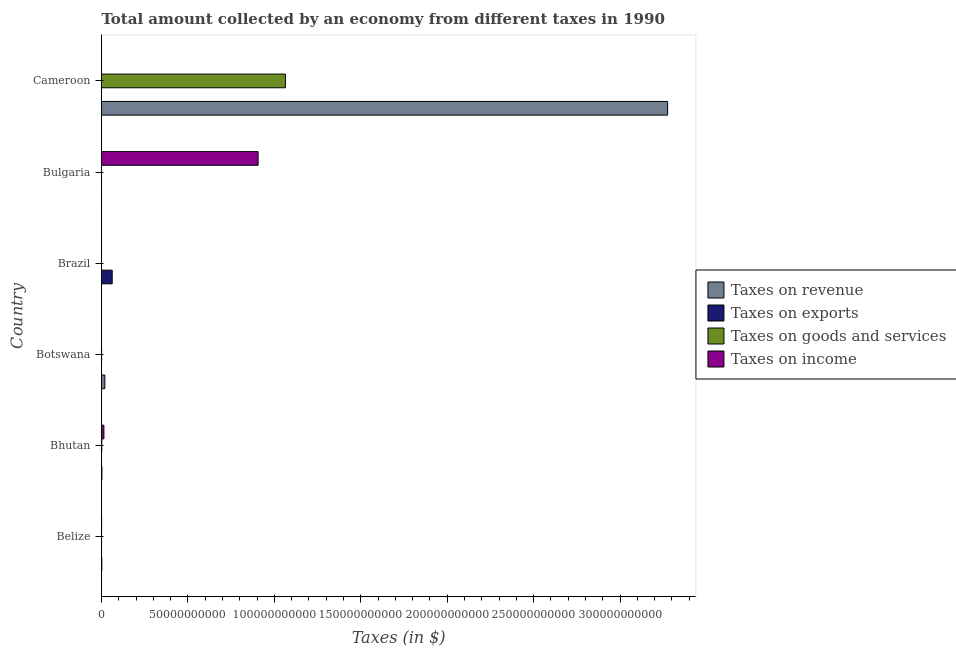How many different coloured bars are there?
Your answer should be compact. 4. How many groups of bars are there?
Your answer should be compact. 6. Are the number of bars on each tick of the Y-axis equal?
Your response must be concise. Yes. How many bars are there on the 2nd tick from the top?
Ensure brevity in your answer.  4. How many bars are there on the 6th tick from the bottom?
Provide a short and direct response. 4. What is the label of the 5th group of bars from the top?
Offer a very short reply. Bhutan. In how many cases, is the number of bars for a given country not equal to the number of legend labels?
Offer a terse response. 0. What is the amount collected as tax on goods in Cameroon?
Your answer should be very brief. 1.06e+11. Across all countries, what is the maximum amount collected as tax on income?
Provide a succinct answer. 9.06e+1. Across all countries, what is the minimum amount collected as tax on income?
Provide a succinct answer. 0.6. In which country was the amount collected as tax on revenue maximum?
Offer a very short reply. Cameroon. In which country was the amount collected as tax on exports minimum?
Your response must be concise. Bulgaria. What is the total amount collected as tax on revenue in the graph?
Offer a terse response. 3.30e+11. What is the difference between the amount collected as tax on revenue in Bhutan and that in Bulgaria?
Provide a short and direct response. 2.21e+08. What is the difference between the amount collected as tax on goods in Botswana and the amount collected as tax on revenue in Bhutan?
Keep it short and to the point. -1.64e+08. What is the average amount collected as tax on goods per country?
Ensure brevity in your answer.  1.78e+1. What is the difference between the amount collected as tax on revenue and amount collected as tax on income in Cameroon?
Give a very brief answer. 3.27e+11. In how many countries, is the amount collected as tax on income greater than 10000000000 $?
Make the answer very short. 1. Is the amount collected as tax on goods in Bulgaria less than that in Cameroon?
Ensure brevity in your answer.  Yes. Is the difference between the amount collected as tax on goods in Brazil and Cameroon greater than the difference between the amount collected as tax on revenue in Brazil and Cameroon?
Make the answer very short. Yes. What is the difference between the highest and the second highest amount collected as tax on income?
Your answer should be very brief. 8.92e+1. What is the difference between the highest and the lowest amount collected as tax on exports?
Give a very brief answer. 6.18e+09. What does the 1st bar from the top in Bulgaria represents?
Your response must be concise. Taxes on income. What does the 1st bar from the bottom in Cameroon represents?
Keep it short and to the point. Taxes on revenue. Is it the case that in every country, the sum of the amount collected as tax on revenue and amount collected as tax on exports is greater than the amount collected as tax on goods?
Ensure brevity in your answer.  Yes. What is the difference between two consecutive major ticks on the X-axis?
Offer a terse response. 5.00e+1. Are the values on the major ticks of X-axis written in scientific E-notation?
Keep it short and to the point. No. Does the graph contain any zero values?
Keep it short and to the point. No. Where does the legend appear in the graph?
Give a very brief answer. Center right. How many legend labels are there?
Give a very brief answer. 4. What is the title of the graph?
Your answer should be compact. Total amount collected by an economy from different taxes in 1990. What is the label or title of the X-axis?
Provide a succinct answer. Taxes (in $). What is the Taxes (in $) in Taxes on revenue in Belize?
Your answer should be very brief. 1.77e+08. What is the Taxes (in $) in Taxes on exports in Belize?
Your response must be concise. 2.60e+06. What is the Taxes (in $) of Taxes on goods and services in Belize?
Make the answer very short. 2.05e+07. What is the Taxes (in $) of Taxes on income in Belize?
Provide a succinct answer. 7.12e+07. What is the Taxes (in $) in Taxes on revenue in Bhutan?
Your answer should be very brief. 2.32e+08. What is the Taxes (in $) in Taxes on exports in Bhutan?
Keep it short and to the point. 4.40e+05. What is the Taxes (in $) in Taxes on goods and services in Bhutan?
Offer a terse response. 1.52e+08. What is the Taxes (in $) in Taxes on income in Bhutan?
Offer a terse response. 1.39e+09. What is the Taxes (in $) of Taxes on revenue in Botswana?
Your response must be concise. 1.94e+09. What is the Taxes (in $) in Taxes on exports in Botswana?
Make the answer very short. 1018.18. What is the Taxes (in $) of Taxes on goods and services in Botswana?
Give a very brief answer. 6.75e+07. What is the Taxes (in $) in Taxes on income in Botswana?
Your answer should be compact. 5.39e+05. What is the Taxes (in $) in Taxes on revenue in Brazil?
Give a very brief answer. 1.39e+06. What is the Taxes (in $) of Taxes on exports in Brazil?
Provide a succinct answer. 6.18e+09. What is the Taxes (in $) of Taxes on goods and services in Brazil?
Make the answer very short. 6.37e+05. What is the Taxes (in $) in Taxes on income in Brazil?
Provide a succinct answer. 6.35e+06. What is the Taxes (in $) of Taxes on revenue in Bulgaria?
Your answer should be compact. 1.08e+07. What is the Taxes (in $) in Taxes on exports in Bulgaria?
Give a very brief answer. 0.09. What is the Taxes (in $) in Taxes on goods and services in Bulgaria?
Offer a very short reply. 3.88e+06. What is the Taxes (in $) of Taxes on income in Bulgaria?
Provide a succinct answer. 9.06e+1. What is the Taxes (in $) of Taxes on revenue in Cameroon?
Keep it short and to the point. 3.27e+11. What is the Taxes (in $) in Taxes on exports in Cameroon?
Provide a succinct answer. 5.00e+06. What is the Taxes (in $) in Taxes on goods and services in Cameroon?
Ensure brevity in your answer.  1.06e+11. What is the Taxes (in $) of Taxes on income in Cameroon?
Your answer should be compact. 0.6. Across all countries, what is the maximum Taxes (in $) in Taxes on revenue?
Provide a short and direct response. 3.27e+11. Across all countries, what is the maximum Taxes (in $) of Taxes on exports?
Offer a very short reply. 6.18e+09. Across all countries, what is the maximum Taxes (in $) of Taxes on goods and services?
Offer a terse response. 1.06e+11. Across all countries, what is the maximum Taxes (in $) in Taxes on income?
Offer a terse response. 9.06e+1. Across all countries, what is the minimum Taxes (in $) in Taxes on revenue?
Provide a short and direct response. 1.39e+06. Across all countries, what is the minimum Taxes (in $) of Taxes on exports?
Your response must be concise. 0.09. Across all countries, what is the minimum Taxes (in $) of Taxes on goods and services?
Keep it short and to the point. 6.37e+05. Across all countries, what is the minimum Taxes (in $) in Taxes on income?
Make the answer very short. 0.6. What is the total Taxes (in $) of Taxes on revenue in the graph?
Keep it short and to the point. 3.30e+11. What is the total Taxes (in $) of Taxes on exports in the graph?
Your answer should be compact. 6.19e+09. What is the total Taxes (in $) of Taxes on goods and services in the graph?
Keep it short and to the point. 1.07e+11. What is the total Taxes (in $) of Taxes on income in the graph?
Keep it short and to the point. 9.21e+1. What is the difference between the Taxes (in $) in Taxes on revenue in Belize and that in Bhutan?
Your answer should be compact. -5.49e+07. What is the difference between the Taxes (in $) in Taxes on exports in Belize and that in Bhutan?
Offer a very short reply. 2.16e+06. What is the difference between the Taxes (in $) of Taxes on goods and services in Belize and that in Bhutan?
Your response must be concise. -1.32e+08. What is the difference between the Taxes (in $) of Taxes on income in Belize and that in Bhutan?
Provide a succinct answer. -1.32e+09. What is the difference between the Taxes (in $) of Taxes on revenue in Belize and that in Botswana?
Your answer should be very brief. -1.76e+09. What is the difference between the Taxes (in $) of Taxes on exports in Belize and that in Botswana?
Your response must be concise. 2.60e+06. What is the difference between the Taxes (in $) of Taxes on goods and services in Belize and that in Botswana?
Ensure brevity in your answer.  -4.70e+07. What is the difference between the Taxes (in $) of Taxes on income in Belize and that in Botswana?
Provide a short and direct response. 7.07e+07. What is the difference between the Taxes (in $) of Taxes on revenue in Belize and that in Brazil?
Offer a terse response. 1.75e+08. What is the difference between the Taxes (in $) of Taxes on exports in Belize and that in Brazil?
Ensure brevity in your answer.  -6.18e+09. What is the difference between the Taxes (in $) of Taxes on goods and services in Belize and that in Brazil?
Your answer should be compact. 1.98e+07. What is the difference between the Taxes (in $) in Taxes on income in Belize and that in Brazil?
Keep it short and to the point. 6.48e+07. What is the difference between the Taxes (in $) of Taxes on revenue in Belize and that in Bulgaria?
Your answer should be compact. 1.66e+08. What is the difference between the Taxes (in $) in Taxes on exports in Belize and that in Bulgaria?
Provide a succinct answer. 2.60e+06. What is the difference between the Taxes (in $) in Taxes on goods and services in Belize and that in Bulgaria?
Offer a terse response. 1.66e+07. What is the difference between the Taxes (in $) in Taxes on income in Belize and that in Bulgaria?
Provide a succinct answer. -9.05e+1. What is the difference between the Taxes (in $) in Taxes on revenue in Belize and that in Cameroon?
Offer a very short reply. -3.27e+11. What is the difference between the Taxes (in $) in Taxes on exports in Belize and that in Cameroon?
Ensure brevity in your answer.  -2.40e+06. What is the difference between the Taxes (in $) of Taxes on goods and services in Belize and that in Cameroon?
Provide a succinct answer. -1.06e+11. What is the difference between the Taxes (in $) of Taxes on income in Belize and that in Cameroon?
Provide a short and direct response. 7.12e+07. What is the difference between the Taxes (in $) of Taxes on revenue in Bhutan and that in Botswana?
Provide a short and direct response. -1.71e+09. What is the difference between the Taxes (in $) in Taxes on exports in Bhutan and that in Botswana?
Your answer should be very brief. 4.39e+05. What is the difference between the Taxes (in $) of Taxes on goods and services in Bhutan and that in Botswana?
Offer a very short reply. 8.46e+07. What is the difference between the Taxes (in $) of Taxes on income in Bhutan and that in Botswana?
Make the answer very short. 1.39e+09. What is the difference between the Taxes (in $) of Taxes on revenue in Bhutan and that in Brazil?
Give a very brief answer. 2.30e+08. What is the difference between the Taxes (in $) of Taxes on exports in Bhutan and that in Brazil?
Provide a succinct answer. -6.18e+09. What is the difference between the Taxes (in $) in Taxes on goods and services in Bhutan and that in Brazil?
Keep it short and to the point. 1.51e+08. What is the difference between the Taxes (in $) of Taxes on income in Bhutan and that in Brazil?
Your answer should be compact. 1.38e+09. What is the difference between the Taxes (in $) in Taxes on revenue in Bhutan and that in Bulgaria?
Provide a short and direct response. 2.21e+08. What is the difference between the Taxes (in $) in Taxes on exports in Bhutan and that in Bulgaria?
Provide a short and direct response. 4.40e+05. What is the difference between the Taxes (in $) in Taxes on goods and services in Bhutan and that in Bulgaria?
Provide a short and direct response. 1.48e+08. What is the difference between the Taxes (in $) in Taxes on income in Bhutan and that in Bulgaria?
Give a very brief answer. -8.92e+1. What is the difference between the Taxes (in $) of Taxes on revenue in Bhutan and that in Cameroon?
Offer a very short reply. -3.27e+11. What is the difference between the Taxes (in $) of Taxes on exports in Bhutan and that in Cameroon?
Your answer should be compact. -4.56e+06. What is the difference between the Taxes (in $) of Taxes on goods and services in Bhutan and that in Cameroon?
Your answer should be very brief. -1.06e+11. What is the difference between the Taxes (in $) in Taxes on income in Bhutan and that in Cameroon?
Make the answer very short. 1.39e+09. What is the difference between the Taxes (in $) in Taxes on revenue in Botswana and that in Brazil?
Provide a succinct answer. 1.94e+09. What is the difference between the Taxes (in $) in Taxes on exports in Botswana and that in Brazil?
Your answer should be very brief. -6.18e+09. What is the difference between the Taxes (in $) in Taxes on goods and services in Botswana and that in Brazil?
Keep it short and to the point. 6.69e+07. What is the difference between the Taxes (in $) of Taxes on income in Botswana and that in Brazil?
Provide a succinct answer. -5.81e+06. What is the difference between the Taxes (in $) in Taxes on revenue in Botswana and that in Bulgaria?
Offer a terse response. 1.93e+09. What is the difference between the Taxes (in $) of Taxes on exports in Botswana and that in Bulgaria?
Offer a very short reply. 1018.1. What is the difference between the Taxes (in $) in Taxes on goods and services in Botswana and that in Bulgaria?
Keep it short and to the point. 6.36e+07. What is the difference between the Taxes (in $) of Taxes on income in Botswana and that in Bulgaria?
Offer a very short reply. -9.06e+1. What is the difference between the Taxes (in $) in Taxes on revenue in Botswana and that in Cameroon?
Ensure brevity in your answer.  -3.26e+11. What is the difference between the Taxes (in $) of Taxes on exports in Botswana and that in Cameroon?
Offer a very short reply. -5.00e+06. What is the difference between the Taxes (in $) of Taxes on goods and services in Botswana and that in Cameroon?
Make the answer very short. -1.06e+11. What is the difference between the Taxes (in $) in Taxes on income in Botswana and that in Cameroon?
Provide a short and direct response. 5.39e+05. What is the difference between the Taxes (in $) in Taxes on revenue in Brazil and that in Bulgaria?
Offer a terse response. -9.43e+06. What is the difference between the Taxes (in $) of Taxes on exports in Brazil and that in Bulgaria?
Offer a very short reply. 6.18e+09. What is the difference between the Taxes (in $) in Taxes on goods and services in Brazil and that in Bulgaria?
Provide a short and direct response. -3.24e+06. What is the difference between the Taxes (in $) in Taxes on income in Brazil and that in Bulgaria?
Make the answer very short. -9.06e+1. What is the difference between the Taxes (in $) of Taxes on revenue in Brazil and that in Cameroon?
Your answer should be compact. -3.27e+11. What is the difference between the Taxes (in $) in Taxes on exports in Brazil and that in Cameroon?
Give a very brief answer. 6.18e+09. What is the difference between the Taxes (in $) in Taxes on goods and services in Brazil and that in Cameroon?
Provide a short and direct response. -1.06e+11. What is the difference between the Taxes (in $) in Taxes on income in Brazil and that in Cameroon?
Your response must be concise. 6.35e+06. What is the difference between the Taxes (in $) of Taxes on revenue in Bulgaria and that in Cameroon?
Offer a very short reply. -3.27e+11. What is the difference between the Taxes (in $) in Taxes on exports in Bulgaria and that in Cameroon?
Provide a succinct answer. -5.00e+06. What is the difference between the Taxes (in $) in Taxes on goods and services in Bulgaria and that in Cameroon?
Your response must be concise. -1.06e+11. What is the difference between the Taxes (in $) of Taxes on income in Bulgaria and that in Cameroon?
Keep it short and to the point. 9.06e+1. What is the difference between the Taxes (in $) in Taxes on revenue in Belize and the Taxes (in $) in Taxes on exports in Bhutan?
Your answer should be very brief. 1.76e+08. What is the difference between the Taxes (in $) of Taxes on revenue in Belize and the Taxes (in $) of Taxes on goods and services in Bhutan?
Give a very brief answer. 2.47e+07. What is the difference between the Taxes (in $) in Taxes on revenue in Belize and the Taxes (in $) in Taxes on income in Bhutan?
Offer a very short reply. -1.21e+09. What is the difference between the Taxes (in $) of Taxes on exports in Belize and the Taxes (in $) of Taxes on goods and services in Bhutan?
Keep it short and to the point. -1.49e+08. What is the difference between the Taxes (in $) of Taxes on exports in Belize and the Taxes (in $) of Taxes on income in Bhutan?
Provide a short and direct response. -1.39e+09. What is the difference between the Taxes (in $) in Taxes on goods and services in Belize and the Taxes (in $) in Taxes on income in Bhutan?
Offer a very short reply. -1.37e+09. What is the difference between the Taxes (in $) of Taxes on revenue in Belize and the Taxes (in $) of Taxes on exports in Botswana?
Your answer should be compact. 1.77e+08. What is the difference between the Taxes (in $) of Taxes on revenue in Belize and the Taxes (in $) of Taxes on goods and services in Botswana?
Provide a short and direct response. 1.09e+08. What is the difference between the Taxes (in $) of Taxes on revenue in Belize and the Taxes (in $) of Taxes on income in Botswana?
Offer a terse response. 1.76e+08. What is the difference between the Taxes (in $) in Taxes on exports in Belize and the Taxes (in $) in Taxes on goods and services in Botswana?
Offer a very short reply. -6.49e+07. What is the difference between the Taxes (in $) of Taxes on exports in Belize and the Taxes (in $) of Taxes on income in Botswana?
Your answer should be very brief. 2.06e+06. What is the difference between the Taxes (in $) in Taxes on goods and services in Belize and the Taxes (in $) in Taxes on income in Botswana?
Your response must be concise. 1.99e+07. What is the difference between the Taxes (in $) of Taxes on revenue in Belize and the Taxes (in $) of Taxes on exports in Brazil?
Your answer should be compact. -6.00e+09. What is the difference between the Taxes (in $) of Taxes on revenue in Belize and the Taxes (in $) of Taxes on goods and services in Brazil?
Offer a very short reply. 1.76e+08. What is the difference between the Taxes (in $) of Taxes on revenue in Belize and the Taxes (in $) of Taxes on income in Brazil?
Keep it short and to the point. 1.70e+08. What is the difference between the Taxes (in $) in Taxes on exports in Belize and the Taxes (in $) in Taxes on goods and services in Brazil?
Offer a terse response. 1.96e+06. What is the difference between the Taxes (in $) of Taxes on exports in Belize and the Taxes (in $) of Taxes on income in Brazil?
Offer a very short reply. -3.75e+06. What is the difference between the Taxes (in $) of Taxes on goods and services in Belize and the Taxes (in $) of Taxes on income in Brazil?
Your answer should be very brief. 1.41e+07. What is the difference between the Taxes (in $) in Taxes on revenue in Belize and the Taxes (in $) in Taxes on exports in Bulgaria?
Provide a short and direct response. 1.77e+08. What is the difference between the Taxes (in $) in Taxes on revenue in Belize and the Taxes (in $) in Taxes on goods and services in Bulgaria?
Provide a short and direct response. 1.73e+08. What is the difference between the Taxes (in $) of Taxes on revenue in Belize and the Taxes (in $) of Taxes on income in Bulgaria?
Keep it short and to the point. -9.04e+1. What is the difference between the Taxes (in $) in Taxes on exports in Belize and the Taxes (in $) in Taxes on goods and services in Bulgaria?
Your response must be concise. -1.27e+06. What is the difference between the Taxes (in $) in Taxes on exports in Belize and the Taxes (in $) in Taxes on income in Bulgaria?
Offer a very short reply. -9.06e+1. What is the difference between the Taxes (in $) in Taxes on goods and services in Belize and the Taxes (in $) in Taxes on income in Bulgaria?
Offer a terse response. -9.06e+1. What is the difference between the Taxes (in $) of Taxes on revenue in Belize and the Taxes (in $) of Taxes on exports in Cameroon?
Give a very brief answer. 1.72e+08. What is the difference between the Taxes (in $) in Taxes on revenue in Belize and the Taxes (in $) in Taxes on goods and services in Cameroon?
Offer a very short reply. -1.06e+11. What is the difference between the Taxes (in $) in Taxes on revenue in Belize and the Taxes (in $) in Taxes on income in Cameroon?
Offer a terse response. 1.77e+08. What is the difference between the Taxes (in $) in Taxes on exports in Belize and the Taxes (in $) in Taxes on goods and services in Cameroon?
Offer a very short reply. -1.06e+11. What is the difference between the Taxes (in $) of Taxes on exports in Belize and the Taxes (in $) of Taxes on income in Cameroon?
Provide a succinct answer. 2.60e+06. What is the difference between the Taxes (in $) in Taxes on goods and services in Belize and the Taxes (in $) in Taxes on income in Cameroon?
Make the answer very short. 2.05e+07. What is the difference between the Taxes (in $) of Taxes on revenue in Bhutan and the Taxes (in $) of Taxes on exports in Botswana?
Your answer should be compact. 2.32e+08. What is the difference between the Taxes (in $) of Taxes on revenue in Bhutan and the Taxes (in $) of Taxes on goods and services in Botswana?
Your answer should be compact. 1.64e+08. What is the difference between the Taxes (in $) of Taxes on revenue in Bhutan and the Taxes (in $) of Taxes on income in Botswana?
Offer a very short reply. 2.31e+08. What is the difference between the Taxes (in $) of Taxes on exports in Bhutan and the Taxes (in $) of Taxes on goods and services in Botswana?
Offer a very short reply. -6.71e+07. What is the difference between the Taxes (in $) in Taxes on exports in Bhutan and the Taxes (in $) in Taxes on income in Botswana?
Your answer should be compact. -9.88e+04. What is the difference between the Taxes (in $) in Taxes on goods and services in Bhutan and the Taxes (in $) in Taxes on income in Botswana?
Your answer should be compact. 1.52e+08. What is the difference between the Taxes (in $) of Taxes on revenue in Bhutan and the Taxes (in $) of Taxes on exports in Brazil?
Make the answer very short. -5.95e+09. What is the difference between the Taxes (in $) of Taxes on revenue in Bhutan and the Taxes (in $) of Taxes on goods and services in Brazil?
Ensure brevity in your answer.  2.31e+08. What is the difference between the Taxes (in $) of Taxes on revenue in Bhutan and the Taxes (in $) of Taxes on income in Brazil?
Your answer should be very brief. 2.25e+08. What is the difference between the Taxes (in $) of Taxes on exports in Bhutan and the Taxes (in $) of Taxes on goods and services in Brazil?
Offer a very short reply. -1.97e+05. What is the difference between the Taxes (in $) of Taxes on exports in Bhutan and the Taxes (in $) of Taxes on income in Brazil?
Keep it short and to the point. -5.91e+06. What is the difference between the Taxes (in $) of Taxes on goods and services in Bhutan and the Taxes (in $) of Taxes on income in Brazil?
Give a very brief answer. 1.46e+08. What is the difference between the Taxes (in $) in Taxes on revenue in Bhutan and the Taxes (in $) in Taxes on exports in Bulgaria?
Provide a short and direct response. 2.32e+08. What is the difference between the Taxes (in $) of Taxes on revenue in Bhutan and the Taxes (in $) of Taxes on goods and services in Bulgaria?
Offer a terse response. 2.28e+08. What is the difference between the Taxes (in $) of Taxes on revenue in Bhutan and the Taxes (in $) of Taxes on income in Bulgaria?
Keep it short and to the point. -9.04e+1. What is the difference between the Taxes (in $) in Taxes on exports in Bhutan and the Taxes (in $) in Taxes on goods and services in Bulgaria?
Your answer should be very brief. -3.44e+06. What is the difference between the Taxes (in $) in Taxes on exports in Bhutan and the Taxes (in $) in Taxes on income in Bulgaria?
Your response must be concise. -9.06e+1. What is the difference between the Taxes (in $) of Taxes on goods and services in Bhutan and the Taxes (in $) of Taxes on income in Bulgaria?
Offer a terse response. -9.04e+1. What is the difference between the Taxes (in $) in Taxes on revenue in Bhutan and the Taxes (in $) in Taxes on exports in Cameroon?
Your answer should be compact. 2.27e+08. What is the difference between the Taxes (in $) in Taxes on revenue in Bhutan and the Taxes (in $) in Taxes on goods and services in Cameroon?
Give a very brief answer. -1.06e+11. What is the difference between the Taxes (in $) of Taxes on revenue in Bhutan and the Taxes (in $) of Taxes on income in Cameroon?
Provide a short and direct response. 2.32e+08. What is the difference between the Taxes (in $) of Taxes on exports in Bhutan and the Taxes (in $) of Taxes on goods and services in Cameroon?
Provide a short and direct response. -1.06e+11. What is the difference between the Taxes (in $) in Taxes on exports in Bhutan and the Taxes (in $) in Taxes on income in Cameroon?
Your answer should be compact. 4.40e+05. What is the difference between the Taxes (in $) of Taxes on goods and services in Bhutan and the Taxes (in $) of Taxes on income in Cameroon?
Ensure brevity in your answer.  1.52e+08. What is the difference between the Taxes (in $) in Taxes on revenue in Botswana and the Taxes (in $) in Taxes on exports in Brazil?
Provide a short and direct response. -4.24e+09. What is the difference between the Taxes (in $) in Taxes on revenue in Botswana and the Taxes (in $) in Taxes on goods and services in Brazil?
Offer a terse response. 1.94e+09. What is the difference between the Taxes (in $) in Taxes on revenue in Botswana and the Taxes (in $) in Taxes on income in Brazil?
Provide a succinct answer. 1.93e+09. What is the difference between the Taxes (in $) of Taxes on exports in Botswana and the Taxes (in $) of Taxes on goods and services in Brazil?
Your answer should be very brief. -6.36e+05. What is the difference between the Taxes (in $) in Taxes on exports in Botswana and the Taxes (in $) in Taxes on income in Brazil?
Your answer should be very brief. -6.35e+06. What is the difference between the Taxes (in $) in Taxes on goods and services in Botswana and the Taxes (in $) in Taxes on income in Brazil?
Ensure brevity in your answer.  6.11e+07. What is the difference between the Taxes (in $) of Taxes on revenue in Botswana and the Taxes (in $) of Taxes on exports in Bulgaria?
Offer a very short reply. 1.94e+09. What is the difference between the Taxes (in $) of Taxes on revenue in Botswana and the Taxes (in $) of Taxes on goods and services in Bulgaria?
Your answer should be compact. 1.94e+09. What is the difference between the Taxes (in $) of Taxes on revenue in Botswana and the Taxes (in $) of Taxes on income in Bulgaria?
Your response must be concise. -8.87e+1. What is the difference between the Taxes (in $) in Taxes on exports in Botswana and the Taxes (in $) in Taxes on goods and services in Bulgaria?
Your answer should be compact. -3.87e+06. What is the difference between the Taxes (in $) in Taxes on exports in Botswana and the Taxes (in $) in Taxes on income in Bulgaria?
Ensure brevity in your answer.  -9.06e+1. What is the difference between the Taxes (in $) of Taxes on goods and services in Botswana and the Taxes (in $) of Taxes on income in Bulgaria?
Your answer should be very brief. -9.05e+1. What is the difference between the Taxes (in $) in Taxes on revenue in Botswana and the Taxes (in $) in Taxes on exports in Cameroon?
Make the answer very short. 1.93e+09. What is the difference between the Taxes (in $) in Taxes on revenue in Botswana and the Taxes (in $) in Taxes on goods and services in Cameroon?
Your answer should be compact. -1.04e+11. What is the difference between the Taxes (in $) in Taxes on revenue in Botswana and the Taxes (in $) in Taxes on income in Cameroon?
Your answer should be very brief. 1.94e+09. What is the difference between the Taxes (in $) in Taxes on exports in Botswana and the Taxes (in $) in Taxes on goods and services in Cameroon?
Offer a terse response. -1.06e+11. What is the difference between the Taxes (in $) in Taxes on exports in Botswana and the Taxes (in $) in Taxes on income in Cameroon?
Give a very brief answer. 1017.58. What is the difference between the Taxes (in $) in Taxes on goods and services in Botswana and the Taxes (in $) in Taxes on income in Cameroon?
Your answer should be very brief. 6.75e+07. What is the difference between the Taxes (in $) of Taxes on revenue in Brazil and the Taxes (in $) of Taxes on exports in Bulgaria?
Offer a very short reply. 1.39e+06. What is the difference between the Taxes (in $) of Taxes on revenue in Brazil and the Taxes (in $) of Taxes on goods and services in Bulgaria?
Provide a short and direct response. -2.49e+06. What is the difference between the Taxes (in $) of Taxes on revenue in Brazil and the Taxes (in $) of Taxes on income in Bulgaria?
Keep it short and to the point. -9.06e+1. What is the difference between the Taxes (in $) of Taxes on exports in Brazil and the Taxes (in $) of Taxes on goods and services in Bulgaria?
Ensure brevity in your answer.  6.18e+09. What is the difference between the Taxes (in $) of Taxes on exports in Brazil and the Taxes (in $) of Taxes on income in Bulgaria?
Provide a succinct answer. -8.44e+1. What is the difference between the Taxes (in $) of Taxes on goods and services in Brazil and the Taxes (in $) of Taxes on income in Bulgaria?
Ensure brevity in your answer.  -9.06e+1. What is the difference between the Taxes (in $) in Taxes on revenue in Brazil and the Taxes (in $) in Taxes on exports in Cameroon?
Keep it short and to the point. -3.61e+06. What is the difference between the Taxes (in $) in Taxes on revenue in Brazil and the Taxes (in $) in Taxes on goods and services in Cameroon?
Make the answer very short. -1.06e+11. What is the difference between the Taxes (in $) in Taxes on revenue in Brazil and the Taxes (in $) in Taxes on income in Cameroon?
Your answer should be compact. 1.39e+06. What is the difference between the Taxes (in $) in Taxes on exports in Brazil and the Taxes (in $) in Taxes on goods and services in Cameroon?
Provide a succinct answer. -1.00e+11. What is the difference between the Taxes (in $) in Taxes on exports in Brazil and the Taxes (in $) in Taxes on income in Cameroon?
Provide a succinct answer. 6.18e+09. What is the difference between the Taxes (in $) of Taxes on goods and services in Brazil and the Taxes (in $) of Taxes on income in Cameroon?
Your response must be concise. 6.37e+05. What is the difference between the Taxes (in $) of Taxes on revenue in Bulgaria and the Taxes (in $) of Taxes on exports in Cameroon?
Offer a terse response. 5.82e+06. What is the difference between the Taxes (in $) of Taxes on revenue in Bulgaria and the Taxes (in $) of Taxes on goods and services in Cameroon?
Make the answer very short. -1.06e+11. What is the difference between the Taxes (in $) of Taxes on revenue in Bulgaria and the Taxes (in $) of Taxes on income in Cameroon?
Give a very brief answer. 1.08e+07. What is the difference between the Taxes (in $) in Taxes on exports in Bulgaria and the Taxes (in $) in Taxes on goods and services in Cameroon?
Make the answer very short. -1.06e+11. What is the difference between the Taxes (in $) of Taxes on exports in Bulgaria and the Taxes (in $) of Taxes on income in Cameroon?
Provide a short and direct response. -0.51. What is the difference between the Taxes (in $) of Taxes on goods and services in Bulgaria and the Taxes (in $) of Taxes on income in Cameroon?
Make the answer very short. 3.87e+06. What is the average Taxes (in $) in Taxes on revenue per country?
Ensure brevity in your answer.  5.50e+1. What is the average Taxes (in $) in Taxes on exports per country?
Make the answer very short. 1.03e+09. What is the average Taxes (in $) in Taxes on goods and services per country?
Offer a terse response. 1.78e+1. What is the average Taxes (in $) of Taxes on income per country?
Ensure brevity in your answer.  1.53e+1. What is the difference between the Taxes (in $) in Taxes on revenue and Taxes (in $) in Taxes on exports in Belize?
Make the answer very short. 1.74e+08. What is the difference between the Taxes (in $) in Taxes on revenue and Taxes (in $) in Taxes on goods and services in Belize?
Provide a succinct answer. 1.56e+08. What is the difference between the Taxes (in $) of Taxes on revenue and Taxes (in $) of Taxes on income in Belize?
Your answer should be compact. 1.06e+08. What is the difference between the Taxes (in $) of Taxes on exports and Taxes (in $) of Taxes on goods and services in Belize?
Your answer should be very brief. -1.79e+07. What is the difference between the Taxes (in $) in Taxes on exports and Taxes (in $) in Taxes on income in Belize?
Offer a very short reply. -6.86e+07. What is the difference between the Taxes (in $) of Taxes on goods and services and Taxes (in $) of Taxes on income in Belize?
Your response must be concise. -5.07e+07. What is the difference between the Taxes (in $) in Taxes on revenue and Taxes (in $) in Taxes on exports in Bhutan?
Give a very brief answer. 2.31e+08. What is the difference between the Taxes (in $) in Taxes on revenue and Taxes (in $) in Taxes on goods and services in Bhutan?
Your answer should be compact. 7.96e+07. What is the difference between the Taxes (in $) in Taxes on revenue and Taxes (in $) in Taxes on income in Bhutan?
Offer a very short reply. -1.16e+09. What is the difference between the Taxes (in $) in Taxes on exports and Taxes (in $) in Taxes on goods and services in Bhutan?
Offer a terse response. -1.52e+08. What is the difference between the Taxes (in $) in Taxes on exports and Taxes (in $) in Taxes on income in Bhutan?
Your answer should be very brief. -1.39e+09. What is the difference between the Taxes (in $) in Taxes on goods and services and Taxes (in $) in Taxes on income in Bhutan?
Provide a short and direct response. -1.24e+09. What is the difference between the Taxes (in $) in Taxes on revenue and Taxes (in $) in Taxes on exports in Botswana?
Offer a very short reply. 1.94e+09. What is the difference between the Taxes (in $) of Taxes on revenue and Taxes (in $) of Taxes on goods and services in Botswana?
Your response must be concise. 1.87e+09. What is the difference between the Taxes (in $) in Taxes on revenue and Taxes (in $) in Taxes on income in Botswana?
Offer a terse response. 1.94e+09. What is the difference between the Taxes (in $) in Taxes on exports and Taxes (in $) in Taxes on goods and services in Botswana?
Make the answer very short. -6.75e+07. What is the difference between the Taxes (in $) in Taxes on exports and Taxes (in $) in Taxes on income in Botswana?
Make the answer very short. -5.38e+05. What is the difference between the Taxes (in $) in Taxes on goods and services and Taxes (in $) in Taxes on income in Botswana?
Provide a short and direct response. 6.70e+07. What is the difference between the Taxes (in $) in Taxes on revenue and Taxes (in $) in Taxes on exports in Brazil?
Make the answer very short. -6.18e+09. What is the difference between the Taxes (in $) in Taxes on revenue and Taxes (in $) in Taxes on goods and services in Brazil?
Give a very brief answer. 7.50e+05. What is the difference between the Taxes (in $) in Taxes on revenue and Taxes (in $) in Taxes on income in Brazil?
Offer a very short reply. -4.97e+06. What is the difference between the Taxes (in $) in Taxes on exports and Taxes (in $) in Taxes on goods and services in Brazil?
Keep it short and to the point. 6.18e+09. What is the difference between the Taxes (in $) of Taxes on exports and Taxes (in $) of Taxes on income in Brazil?
Your answer should be very brief. 6.17e+09. What is the difference between the Taxes (in $) of Taxes on goods and services and Taxes (in $) of Taxes on income in Brazil?
Make the answer very short. -5.72e+06. What is the difference between the Taxes (in $) of Taxes on revenue and Taxes (in $) of Taxes on exports in Bulgaria?
Your answer should be very brief. 1.08e+07. What is the difference between the Taxes (in $) in Taxes on revenue and Taxes (in $) in Taxes on goods and services in Bulgaria?
Keep it short and to the point. 6.94e+06. What is the difference between the Taxes (in $) in Taxes on revenue and Taxes (in $) in Taxes on income in Bulgaria?
Keep it short and to the point. -9.06e+1. What is the difference between the Taxes (in $) in Taxes on exports and Taxes (in $) in Taxes on goods and services in Bulgaria?
Provide a succinct answer. -3.87e+06. What is the difference between the Taxes (in $) in Taxes on exports and Taxes (in $) in Taxes on income in Bulgaria?
Make the answer very short. -9.06e+1. What is the difference between the Taxes (in $) in Taxes on goods and services and Taxes (in $) in Taxes on income in Bulgaria?
Provide a short and direct response. -9.06e+1. What is the difference between the Taxes (in $) in Taxes on revenue and Taxes (in $) in Taxes on exports in Cameroon?
Provide a succinct answer. 3.27e+11. What is the difference between the Taxes (in $) in Taxes on revenue and Taxes (in $) in Taxes on goods and services in Cameroon?
Ensure brevity in your answer.  2.21e+11. What is the difference between the Taxes (in $) in Taxes on revenue and Taxes (in $) in Taxes on income in Cameroon?
Offer a terse response. 3.27e+11. What is the difference between the Taxes (in $) in Taxes on exports and Taxes (in $) in Taxes on goods and services in Cameroon?
Give a very brief answer. -1.06e+11. What is the difference between the Taxes (in $) of Taxes on exports and Taxes (in $) of Taxes on income in Cameroon?
Ensure brevity in your answer.  5.00e+06. What is the difference between the Taxes (in $) in Taxes on goods and services and Taxes (in $) in Taxes on income in Cameroon?
Make the answer very short. 1.06e+11. What is the ratio of the Taxes (in $) of Taxes on revenue in Belize to that in Bhutan?
Keep it short and to the point. 0.76. What is the ratio of the Taxes (in $) in Taxes on exports in Belize to that in Bhutan?
Make the answer very short. 5.91. What is the ratio of the Taxes (in $) in Taxes on goods and services in Belize to that in Bhutan?
Your answer should be compact. 0.13. What is the ratio of the Taxes (in $) of Taxes on income in Belize to that in Bhutan?
Your response must be concise. 0.05. What is the ratio of the Taxes (in $) of Taxes on revenue in Belize to that in Botswana?
Provide a succinct answer. 0.09. What is the ratio of the Taxes (in $) of Taxes on exports in Belize to that in Botswana?
Offer a terse response. 2554.55. What is the ratio of the Taxes (in $) of Taxes on goods and services in Belize to that in Botswana?
Ensure brevity in your answer.  0.3. What is the ratio of the Taxes (in $) in Taxes on income in Belize to that in Botswana?
Provide a short and direct response. 132.15. What is the ratio of the Taxes (in $) of Taxes on revenue in Belize to that in Brazil?
Your response must be concise. 127.5. What is the ratio of the Taxes (in $) in Taxes on exports in Belize to that in Brazil?
Your answer should be compact. 0. What is the ratio of the Taxes (in $) of Taxes on goods and services in Belize to that in Brazil?
Offer a very short reply. 32.16. What is the ratio of the Taxes (in $) of Taxes on income in Belize to that in Brazil?
Offer a terse response. 11.21. What is the ratio of the Taxes (in $) of Taxes on revenue in Belize to that in Bulgaria?
Your answer should be compact. 16.35. What is the ratio of the Taxes (in $) of Taxes on exports in Belize to that in Bulgaria?
Provide a succinct answer. 3.03e+07. What is the ratio of the Taxes (in $) in Taxes on goods and services in Belize to that in Bulgaria?
Make the answer very short. 5.29. What is the ratio of the Taxes (in $) in Taxes on income in Belize to that in Bulgaria?
Make the answer very short. 0. What is the ratio of the Taxes (in $) of Taxes on revenue in Belize to that in Cameroon?
Offer a very short reply. 0. What is the ratio of the Taxes (in $) of Taxes on exports in Belize to that in Cameroon?
Ensure brevity in your answer.  0.52. What is the ratio of the Taxes (in $) of Taxes on income in Belize to that in Cameroon?
Your response must be concise. 1.19e+08. What is the ratio of the Taxes (in $) of Taxes on revenue in Bhutan to that in Botswana?
Give a very brief answer. 0.12. What is the ratio of the Taxes (in $) in Taxes on exports in Bhutan to that in Botswana?
Ensure brevity in your answer.  432.14. What is the ratio of the Taxes (in $) of Taxes on goods and services in Bhutan to that in Botswana?
Your answer should be compact. 2.25. What is the ratio of the Taxes (in $) of Taxes on income in Bhutan to that in Botswana?
Offer a very short reply. 2581.29. What is the ratio of the Taxes (in $) in Taxes on revenue in Bhutan to that in Brazil?
Your answer should be compact. 167.06. What is the ratio of the Taxes (in $) of Taxes on goods and services in Bhutan to that in Brazil?
Give a very brief answer. 238.74. What is the ratio of the Taxes (in $) of Taxes on income in Bhutan to that in Brazil?
Ensure brevity in your answer.  218.92. What is the ratio of the Taxes (in $) in Taxes on revenue in Bhutan to that in Bulgaria?
Your answer should be compact. 21.42. What is the ratio of the Taxes (in $) in Taxes on exports in Bhutan to that in Bulgaria?
Your answer should be compact. 5.13e+06. What is the ratio of the Taxes (in $) of Taxes on goods and services in Bhutan to that in Bulgaria?
Ensure brevity in your answer.  39.25. What is the ratio of the Taxes (in $) of Taxes on income in Bhutan to that in Bulgaria?
Provide a succinct answer. 0.02. What is the ratio of the Taxes (in $) in Taxes on revenue in Bhutan to that in Cameroon?
Your answer should be compact. 0. What is the ratio of the Taxes (in $) of Taxes on exports in Bhutan to that in Cameroon?
Your answer should be very brief. 0.09. What is the ratio of the Taxes (in $) of Taxes on goods and services in Bhutan to that in Cameroon?
Give a very brief answer. 0. What is the ratio of the Taxes (in $) of Taxes on income in Bhutan to that in Cameroon?
Your response must be concise. 2.32e+09. What is the ratio of the Taxes (in $) of Taxes on revenue in Botswana to that in Brazil?
Offer a very short reply. 1398.44. What is the ratio of the Taxes (in $) in Taxes on exports in Botswana to that in Brazil?
Offer a very short reply. 0. What is the ratio of the Taxes (in $) of Taxes on goods and services in Botswana to that in Brazil?
Your response must be concise. 105.95. What is the ratio of the Taxes (in $) of Taxes on income in Botswana to that in Brazil?
Keep it short and to the point. 0.08. What is the ratio of the Taxes (in $) of Taxes on revenue in Botswana to that in Bulgaria?
Offer a very short reply. 179.29. What is the ratio of the Taxes (in $) in Taxes on exports in Botswana to that in Bulgaria?
Provide a short and direct response. 1.19e+04. What is the ratio of the Taxes (in $) of Taxes on goods and services in Botswana to that in Bulgaria?
Ensure brevity in your answer.  17.42. What is the ratio of the Taxes (in $) in Taxes on revenue in Botswana to that in Cameroon?
Provide a succinct answer. 0.01. What is the ratio of the Taxes (in $) of Taxes on exports in Botswana to that in Cameroon?
Your response must be concise. 0. What is the ratio of the Taxes (in $) in Taxes on goods and services in Botswana to that in Cameroon?
Your response must be concise. 0. What is the ratio of the Taxes (in $) in Taxes on income in Botswana to that in Cameroon?
Your answer should be very brief. 8.97e+05. What is the ratio of the Taxes (in $) of Taxes on revenue in Brazil to that in Bulgaria?
Your answer should be compact. 0.13. What is the ratio of the Taxes (in $) in Taxes on exports in Brazil to that in Bulgaria?
Your response must be concise. 7.21e+1. What is the ratio of the Taxes (in $) of Taxes on goods and services in Brazil to that in Bulgaria?
Offer a very short reply. 0.16. What is the ratio of the Taxes (in $) of Taxes on income in Brazil to that in Bulgaria?
Give a very brief answer. 0. What is the ratio of the Taxes (in $) in Taxes on exports in Brazil to that in Cameroon?
Give a very brief answer. 1236. What is the ratio of the Taxes (in $) of Taxes on income in Brazil to that in Cameroon?
Make the answer very short. 1.06e+07. What is the ratio of the Taxes (in $) in Taxes on revenue in Bulgaria to that in Cameroon?
Your answer should be compact. 0. What is the ratio of the Taxes (in $) of Taxes on income in Bulgaria to that in Cameroon?
Give a very brief answer. 1.51e+11. What is the difference between the highest and the second highest Taxes (in $) of Taxes on revenue?
Provide a succinct answer. 3.26e+11. What is the difference between the highest and the second highest Taxes (in $) of Taxes on exports?
Provide a succinct answer. 6.18e+09. What is the difference between the highest and the second highest Taxes (in $) in Taxes on goods and services?
Your answer should be very brief. 1.06e+11. What is the difference between the highest and the second highest Taxes (in $) of Taxes on income?
Offer a very short reply. 8.92e+1. What is the difference between the highest and the lowest Taxes (in $) in Taxes on revenue?
Ensure brevity in your answer.  3.27e+11. What is the difference between the highest and the lowest Taxes (in $) in Taxes on exports?
Give a very brief answer. 6.18e+09. What is the difference between the highest and the lowest Taxes (in $) in Taxes on goods and services?
Ensure brevity in your answer.  1.06e+11. What is the difference between the highest and the lowest Taxes (in $) of Taxes on income?
Offer a very short reply. 9.06e+1. 